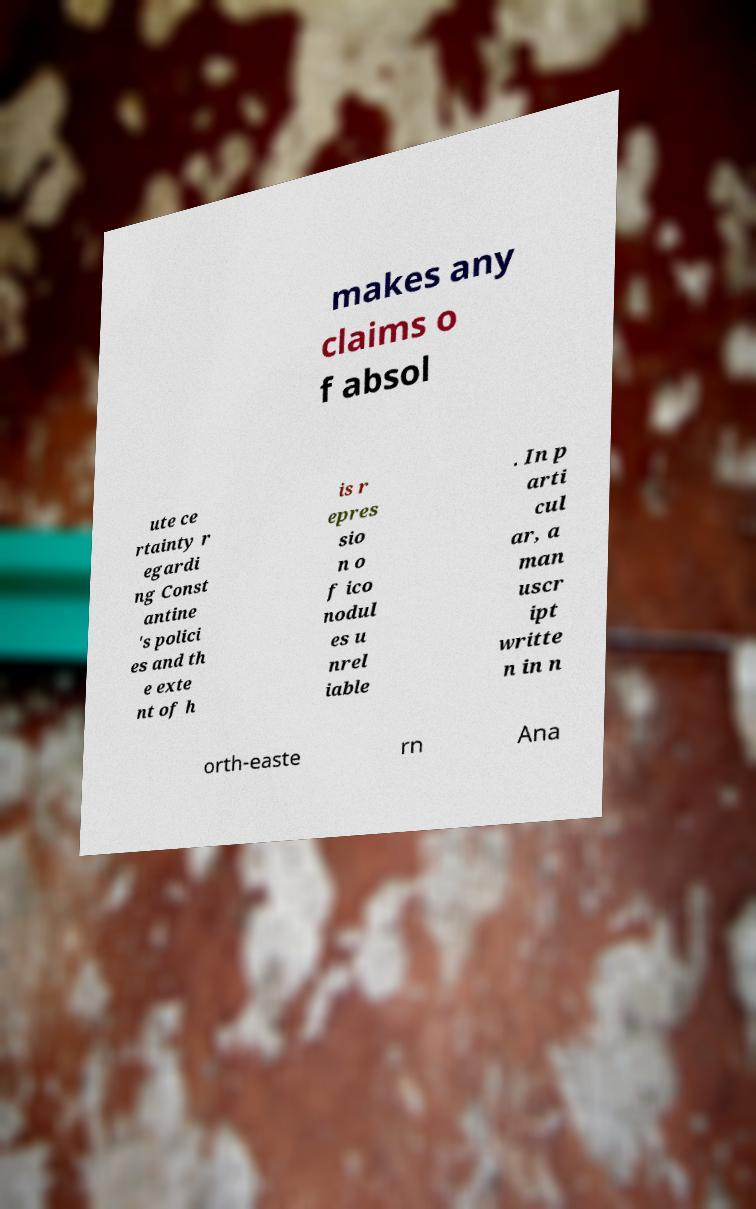For documentation purposes, I need the text within this image transcribed. Could you provide that? makes any claims o f absol ute ce rtainty r egardi ng Const antine 's polici es and th e exte nt of h is r epres sio n o f ico nodul es u nrel iable . In p arti cul ar, a man uscr ipt writte n in n orth-easte rn Ana 